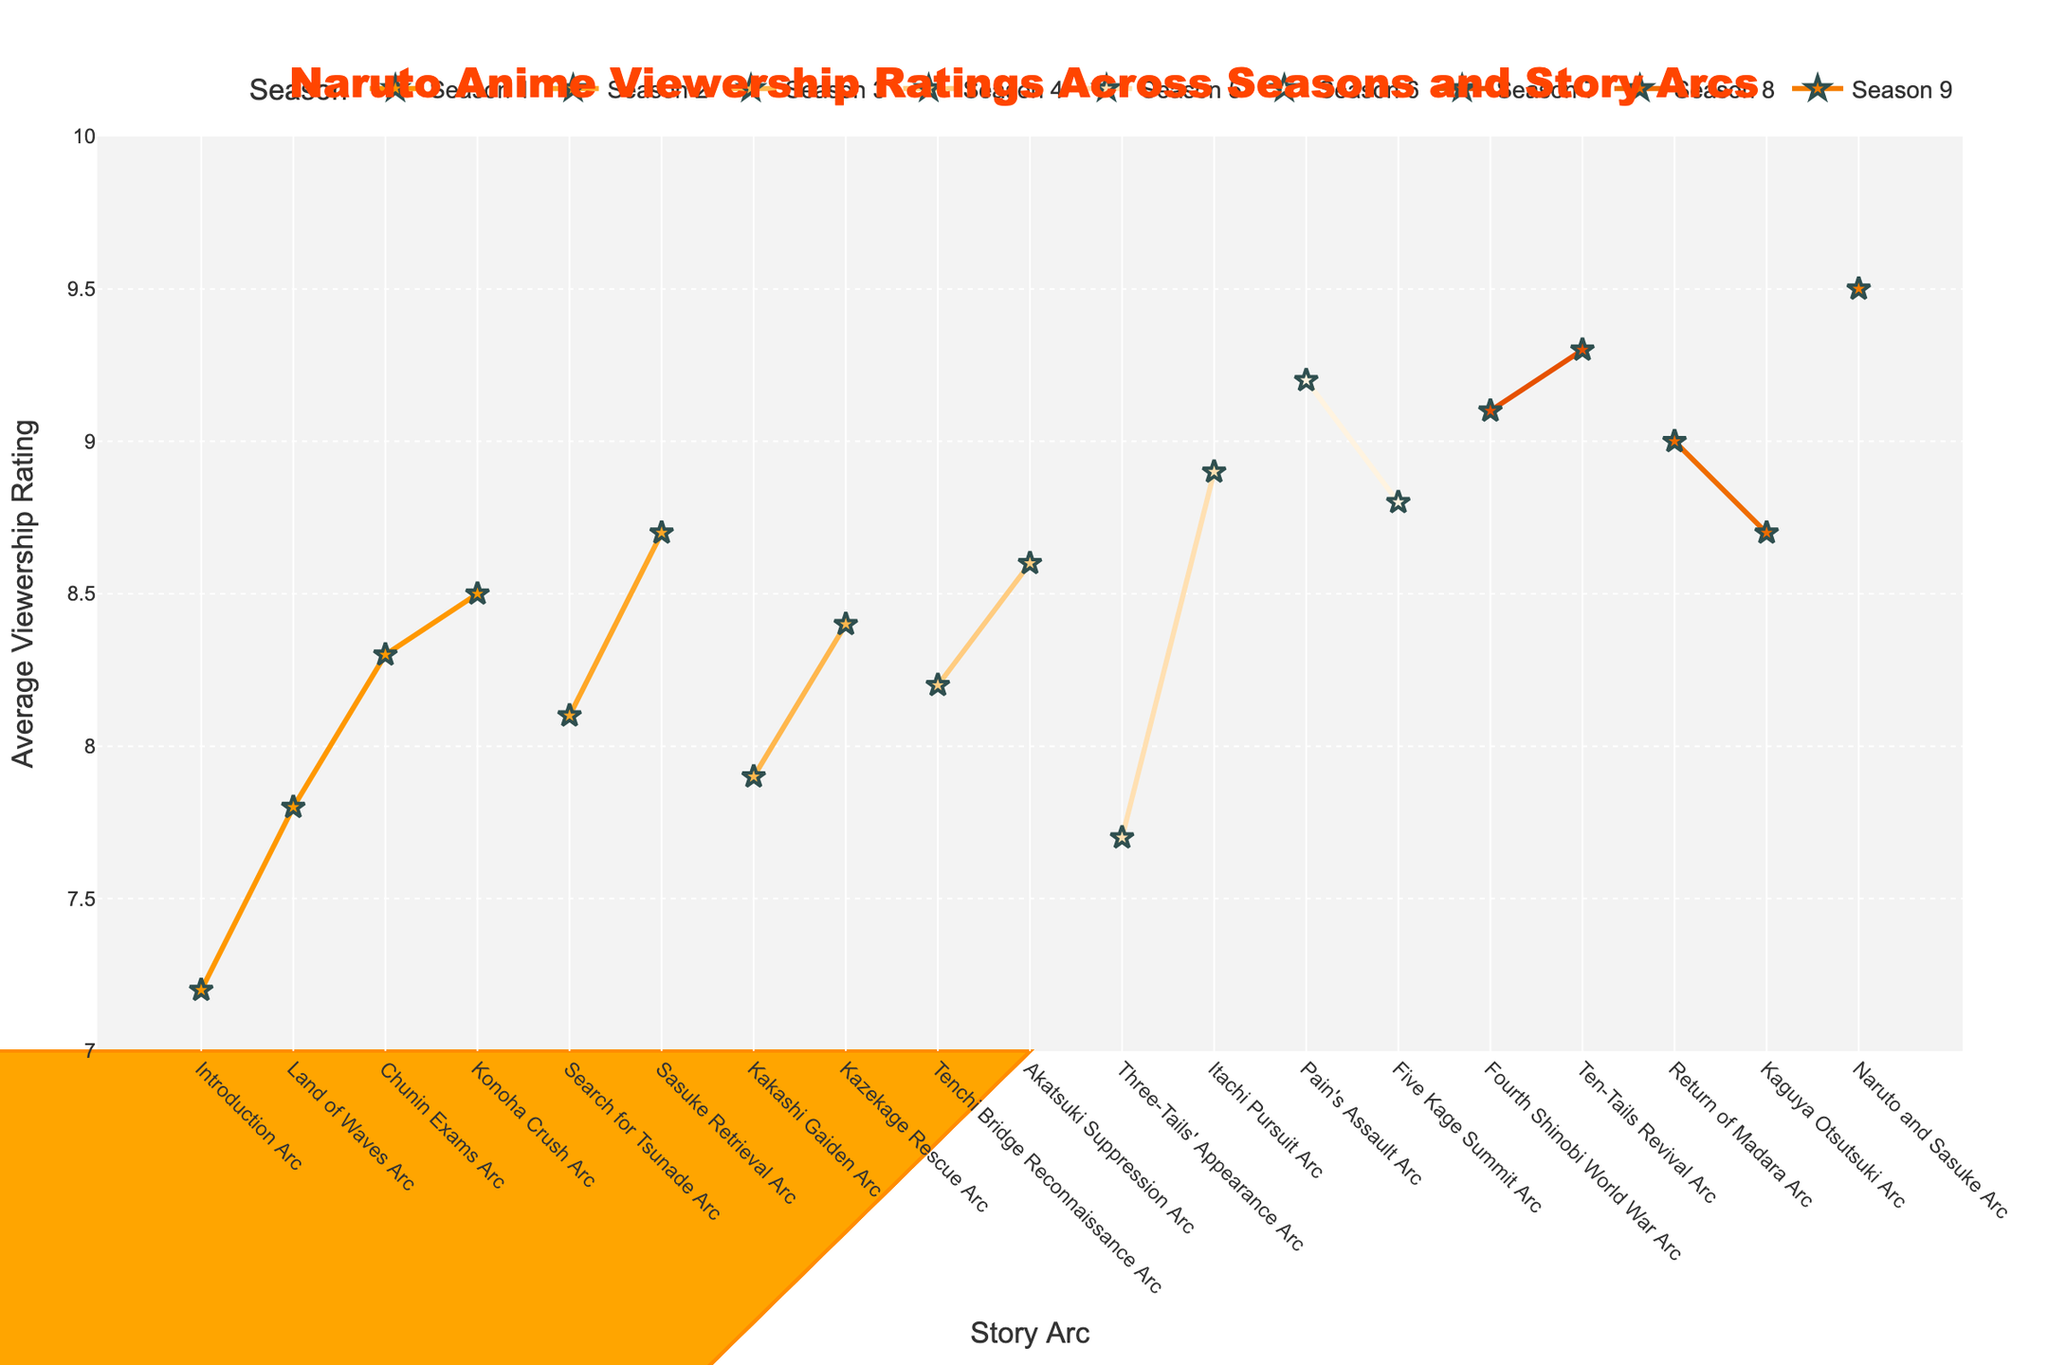Which story arc has the highest average viewership rating? The figure shows viewership ratings across different story arcs. By scanning the y-axis values and the arcs, the highest rating is associated with the "Naruto and Sasuke Arc".
Answer: Naruto and Sasuke Arc Which season has the most consistently high ratings? Observe the line plots for each season. The season with the smallest range of ratings, where ratings remain consistently high, is Season 9.
Answer: Season 9 What is the average rating for story arcs in Season 5? Add the ratings for the arcs in Season 5: (7.7 + 8.9) and divide by the number of arcs (2). That is (7.7 + 8.9) / 2 = 8.3.
Answer: 8.3 How many story arcs have a rating of 9.0 or higher? Count the arcs on the figure with ratings at or above the 9.0 mark on the y-axis. The arcs are "Pain's Assault Arc", "Fourth Shinobi World War Arc", "Ten-Tails Revival Arc", "Return of Madara Arc", "Naruto and Sasuke Arc", making it 5 arcs.
Answer: 5 What is the difference between the highest and lowest ratings in Season 6? Look at Season 6’s arcs and their ratings: (9.2 - 8.8). The highest rating is 9.2, and the lowest is 8.8, resulting in a difference of 9.2 - 8.8 = 0.4.
Answer: 0.4 How many seasons have at least one story arc with a rating above 9.0? Identify the seasons with arcs rating above 9.0, those are Season 6, Season 7, Season 8, and Season 9. Therefore, there are 4 seasons.
Answer: 4 Which season's viewership starts lower but then finishes with a high rating? Inspect the line trends for each season, Season 9 starts lower but ends the last arc with the highest rating of 9.5.
Answer: Season 9 What is the lowest rated arc in Season 4? Find Season 4’s arcs and viewership ratings. The lowest rating arc is the "Tenchi Bridge Reconnaissance Arc" rated at 8.2.
Answer: Tenchi Bridge Reconnaissance Arc Between the "Search for Tsunade Arc" in Season 2 and the "Kakashi Gaiden Arc" in Season 3, which one has a higher rating? Compare the y-axis ratings of the two arcs. Season 2’s "Search for Tsunade Arc" is at 8.1, and Season 3’s "Kakashi Gaiden Arc" is at 7.9, so the former is higher.
Answer: Search for Tsunade Arc 